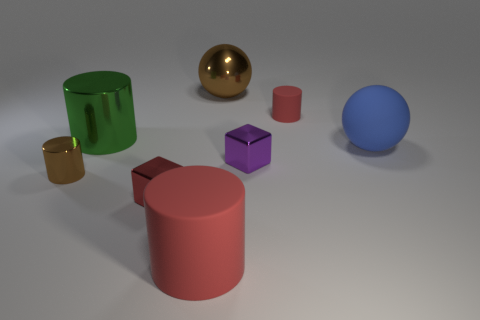What can you infer about the materials of the objects shown? Based on their reflections and surfaces, it appears that the objects are made from various materials. The green cylinder and the blue sphere have a matte finish indicative of metal or plastic. The golden sphere and cube have a reflective surface suggesting they are metallic, while the red cylinder seems to be made of a more diffuse, possibly painted, material. The purple cube also appears to be metallic, given its slight reflection and sheen. 